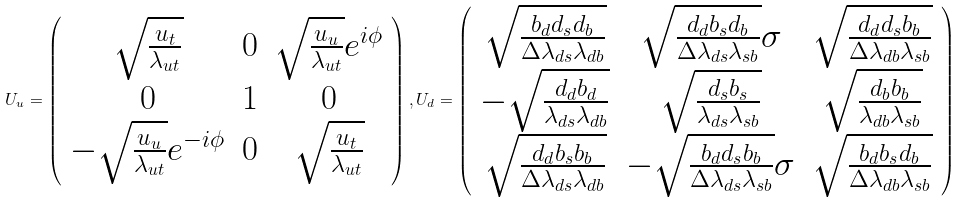<formula> <loc_0><loc_0><loc_500><loc_500>U _ { u } = \left ( \begin{array} { c c c } \sqrt { \frac { u _ { t } } { \lambda _ { u t } } } & 0 & \sqrt { \frac { u _ { u } } { \lambda _ { u t } } } e ^ { i \phi } \\ 0 & 1 & 0 \\ - \sqrt { \frac { u _ { u } } { \lambda _ { u t } } } e ^ { - i \phi } & 0 & \sqrt { \frac { u _ { t } } { \lambda _ { u t } } } \end{array} \right ) , U _ { d } = \left ( \begin{array} { c c c } \sqrt { \frac { b _ { d } d _ { s } d _ { b } } { \Delta \lambda _ { d s } \lambda _ { d b } } } & \sqrt { \frac { d _ { d } b _ { s } d _ { b } } { \Delta \lambda _ { d s } \lambda _ { s b } } } \sigma & \sqrt { \frac { d _ { d } d _ { s } b _ { b } } { \Delta \lambda _ { d b } \lambda _ { s b } } } \\ - \sqrt { \frac { d _ { d } b _ { d } } { \lambda _ { d s } \lambda _ { d b } } } & \sqrt { \frac { d _ { s } b _ { s } } { \lambda _ { d s } \lambda _ { s b } } } & \sqrt { \frac { d _ { b } b _ { b } } { \lambda _ { d b } \lambda _ { s b } } } \\ \sqrt { \frac { d _ { d } b _ { s } b _ { b } } { \Delta \lambda _ { d s } \lambda _ { d b } } } & - \sqrt { \frac { b _ { d } d _ { s } b _ { b } } { \Delta \lambda _ { d s } \lambda _ { s b } } } \sigma & \sqrt { \frac { b _ { d } b _ { s } d _ { b } } { \Delta \lambda _ { d b } \lambda _ { s b } } } \end{array} \right )</formula> 